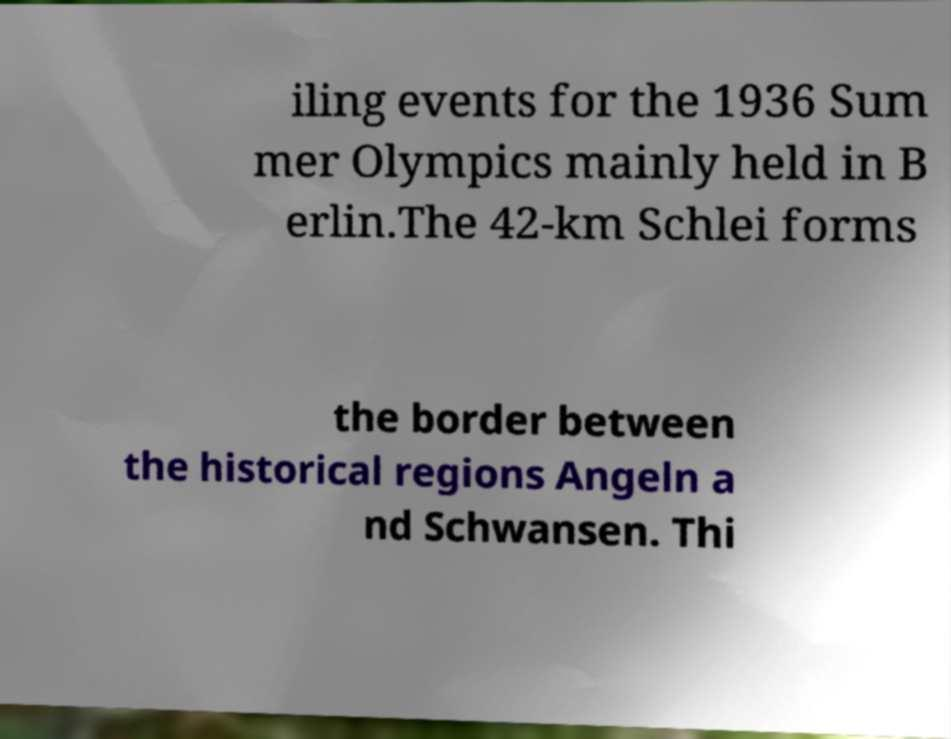Could you assist in decoding the text presented in this image and type it out clearly? iling events for the 1936 Sum mer Olympics mainly held in B erlin.The 42-km Schlei forms the border between the historical regions Angeln a nd Schwansen. Thi 